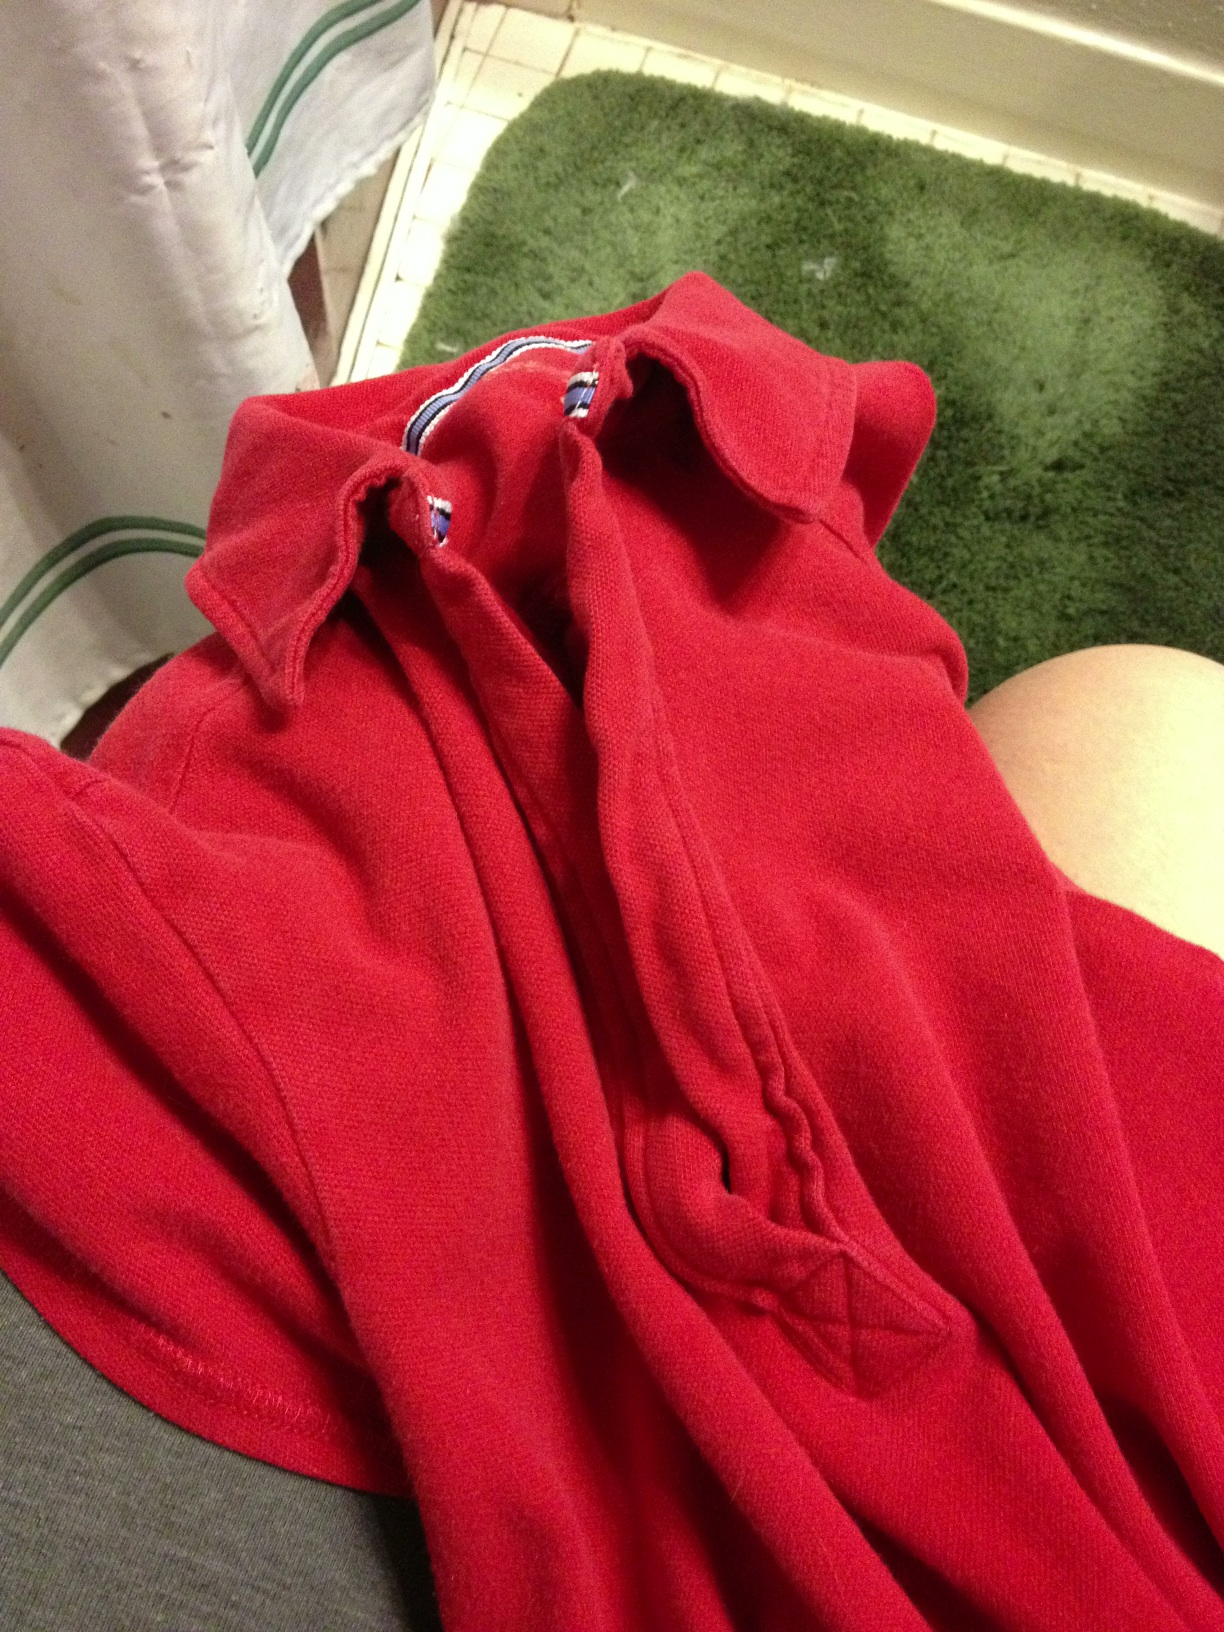What color is this shirt? The shirt in the image is a vibrant red color, featuring a rich and bold hue that stands out prominently. 